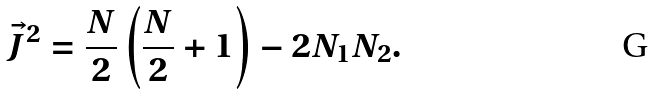<formula> <loc_0><loc_0><loc_500><loc_500>\vec { J } ^ { 2 } = \frac { N } { 2 } \left ( \frac { N } { 2 } + 1 \right ) - 2 N _ { 1 } N _ { 2 } .</formula> 